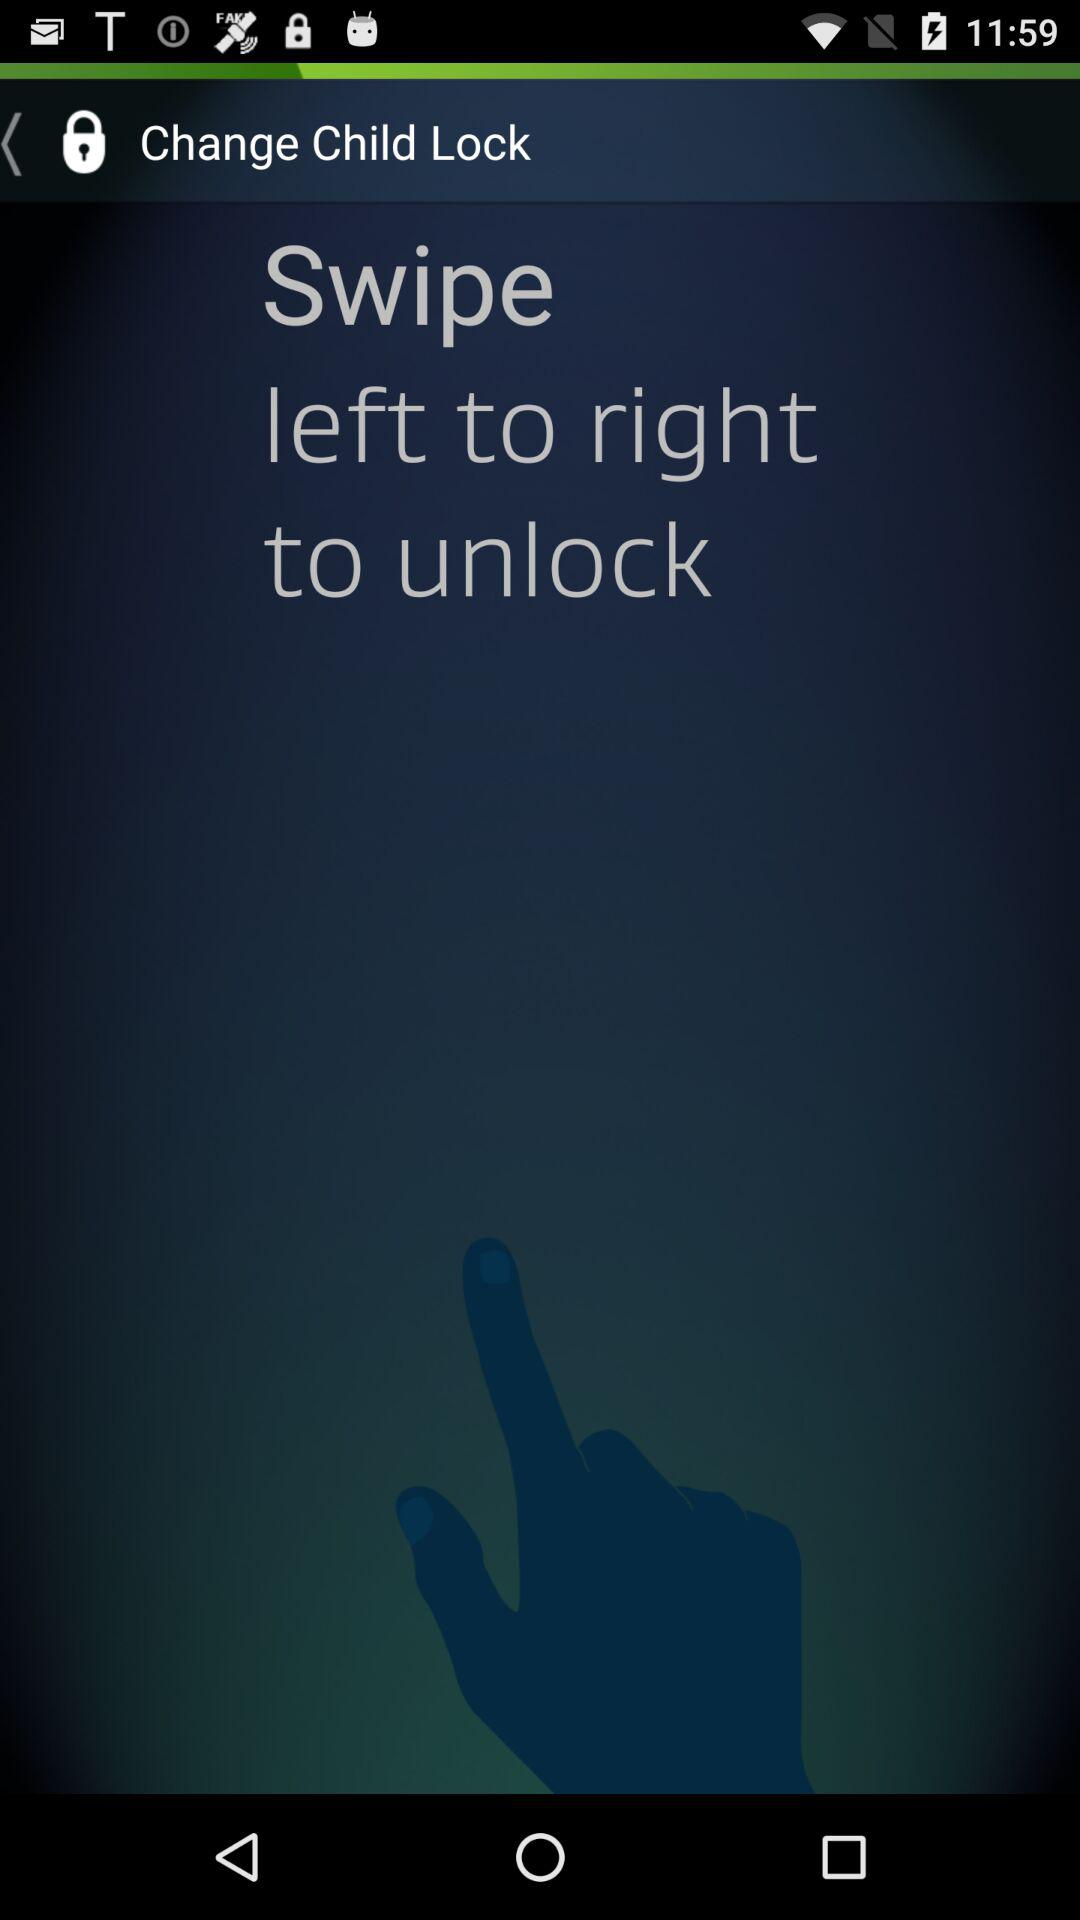To unlock, from which side should it be swiped? It should be swiped from the left side. 